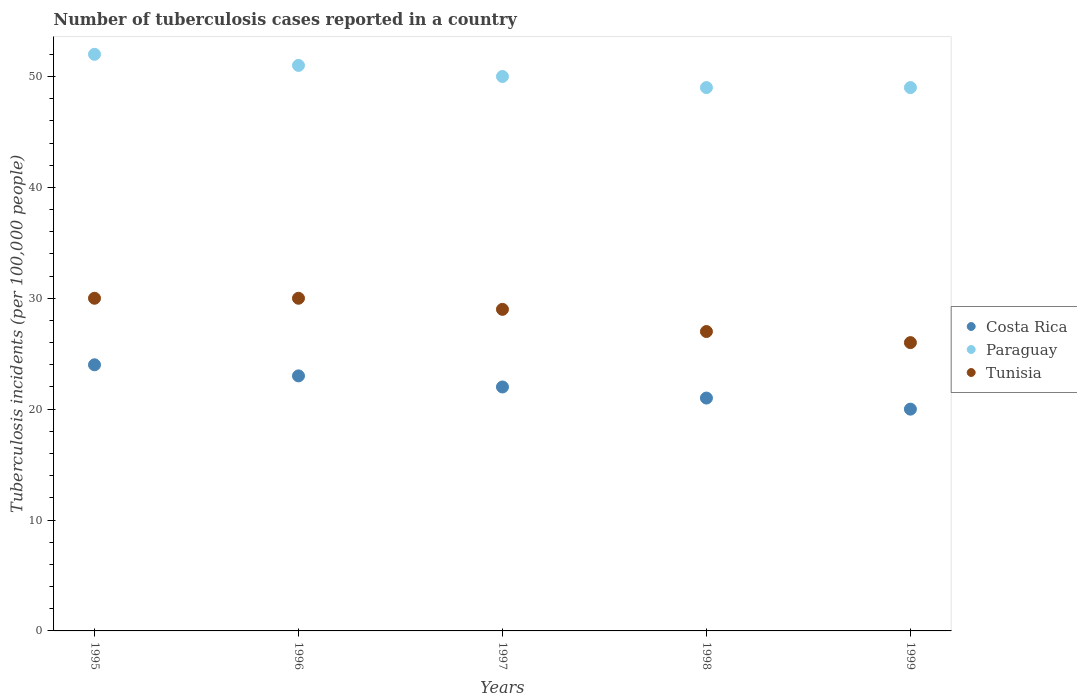What is the number of tuberculosis cases reported in in Paraguay in 1997?
Your answer should be very brief. 50. Across all years, what is the maximum number of tuberculosis cases reported in in Paraguay?
Ensure brevity in your answer.  52. Across all years, what is the minimum number of tuberculosis cases reported in in Tunisia?
Your response must be concise. 26. In which year was the number of tuberculosis cases reported in in Tunisia maximum?
Keep it short and to the point. 1995. What is the total number of tuberculosis cases reported in in Paraguay in the graph?
Provide a succinct answer. 251. What is the difference between the number of tuberculosis cases reported in in Paraguay in 1997 and that in 1999?
Your answer should be very brief. 1. What is the difference between the number of tuberculosis cases reported in in Paraguay in 1997 and the number of tuberculosis cases reported in in Tunisia in 1999?
Your response must be concise. 24. What is the average number of tuberculosis cases reported in in Tunisia per year?
Your answer should be very brief. 28.4. In the year 1996, what is the difference between the number of tuberculosis cases reported in in Costa Rica and number of tuberculosis cases reported in in Tunisia?
Give a very brief answer. -7. In how many years, is the number of tuberculosis cases reported in in Paraguay greater than 40?
Keep it short and to the point. 5. What is the ratio of the number of tuberculosis cases reported in in Costa Rica in 1996 to that in 1999?
Keep it short and to the point. 1.15. Is the number of tuberculosis cases reported in in Tunisia in 1996 less than that in 1997?
Ensure brevity in your answer.  No. Is the difference between the number of tuberculosis cases reported in in Costa Rica in 1995 and 1998 greater than the difference between the number of tuberculosis cases reported in in Tunisia in 1995 and 1998?
Make the answer very short. No. What is the difference between the highest and the second highest number of tuberculosis cases reported in in Tunisia?
Offer a terse response. 0. What is the difference between the highest and the lowest number of tuberculosis cases reported in in Costa Rica?
Your answer should be compact. 4. Is the sum of the number of tuberculosis cases reported in in Costa Rica in 1997 and 1998 greater than the maximum number of tuberculosis cases reported in in Paraguay across all years?
Your response must be concise. No. Is the number of tuberculosis cases reported in in Costa Rica strictly less than the number of tuberculosis cases reported in in Tunisia over the years?
Your answer should be very brief. Yes. How many years are there in the graph?
Provide a succinct answer. 5. Are the values on the major ticks of Y-axis written in scientific E-notation?
Your answer should be compact. No. Does the graph contain any zero values?
Offer a terse response. No. Does the graph contain grids?
Provide a succinct answer. No. How are the legend labels stacked?
Provide a succinct answer. Vertical. What is the title of the graph?
Make the answer very short. Number of tuberculosis cases reported in a country. What is the label or title of the X-axis?
Offer a terse response. Years. What is the label or title of the Y-axis?
Your answer should be compact. Tuberculosis incidents (per 100,0 people). What is the Tuberculosis incidents (per 100,000 people) in Paraguay in 1995?
Give a very brief answer. 52. What is the Tuberculosis incidents (per 100,000 people) in Tunisia in 1996?
Offer a terse response. 30. What is the Tuberculosis incidents (per 100,000 people) in Paraguay in 1997?
Keep it short and to the point. 50. What is the Tuberculosis incidents (per 100,000 people) of Costa Rica in 1998?
Your answer should be compact. 21. What is the Tuberculosis incidents (per 100,000 people) in Paraguay in 1999?
Offer a terse response. 49. What is the Tuberculosis incidents (per 100,000 people) of Tunisia in 1999?
Your answer should be very brief. 26. Across all years, what is the maximum Tuberculosis incidents (per 100,000 people) of Costa Rica?
Your response must be concise. 24. Across all years, what is the maximum Tuberculosis incidents (per 100,000 people) in Paraguay?
Ensure brevity in your answer.  52. Across all years, what is the maximum Tuberculosis incidents (per 100,000 people) of Tunisia?
Your answer should be very brief. 30. Across all years, what is the minimum Tuberculosis incidents (per 100,000 people) in Costa Rica?
Keep it short and to the point. 20. Across all years, what is the minimum Tuberculosis incidents (per 100,000 people) of Tunisia?
Keep it short and to the point. 26. What is the total Tuberculosis incidents (per 100,000 people) in Costa Rica in the graph?
Offer a very short reply. 110. What is the total Tuberculosis incidents (per 100,000 people) in Paraguay in the graph?
Keep it short and to the point. 251. What is the total Tuberculosis incidents (per 100,000 people) of Tunisia in the graph?
Your answer should be compact. 142. What is the difference between the Tuberculosis incidents (per 100,000 people) of Paraguay in 1995 and that in 1996?
Make the answer very short. 1. What is the difference between the Tuberculosis incidents (per 100,000 people) of Costa Rica in 1995 and that in 1997?
Offer a very short reply. 2. What is the difference between the Tuberculosis incidents (per 100,000 people) in Paraguay in 1995 and that in 1997?
Your response must be concise. 2. What is the difference between the Tuberculosis incidents (per 100,000 people) of Costa Rica in 1995 and that in 1998?
Make the answer very short. 3. What is the difference between the Tuberculosis incidents (per 100,000 people) in Paraguay in 1995 and that in 1998?
Your answer should be compact. 3. What is the difference between the Tuberculosis incidents (per 100,000 people) in Paraguay in 1995 and that in 1999?
Ensure brevity in your answer.  3. What is the difference between the Tuberculosis incidents (per 100,000 people) of Paraguay in 1996 and that in 1997?
Your answer should be compact. 1. What is the difference between the Tuberculosis incidents (per 100,000 people) of Paraguay in 1996 and that in 1998?
Your answer should be compact. 2. What is the difference between the Tuberculosis incidents (per 100,000 people) in Tunisia in 1996 and that in 1998?
Provide a short and direct response. 3. What is the difference between the Tuberculosis incidents (per 100,000 people) in Paraguay in 1996 and that in 1999?
Make the answer very short. 2. What is the difference between the Tuberculosis incidents (per 100,000 people) of Tunisia in 1996 and that in 1999?
Provide a short and direct response. 4. What is the difference between the Tuberculosis incidents (per 100,000 people) of Costa Rica in 1997 and that in 1998?
Provide a short and direct response. 1. What is the difference between the Tuberculosis incidents (per 100,000 people) in Paraguay in 1997 and that in 1998?
Ensure brevity in your answer.  1. What is the difference between the Tuberculosis incidents (per 100,000 people) of Tunisia in 1997 and that in 1998?
Ensure brevity in your answer.  2. What is the difference between the Tuberculosis incidents (per 100,000 people) in Costa Rica in 1997 and that in 1999?
Ensure brevity in your answer.  2. What is the difference between the Tuberculosis incidents (per 100,000 people) of Paraguay in 1997 and that in 1999?
Provide a succinct answer. 1. What is the difference between the Tuberculosis incidents (per 100,000 people) in Costa Rica in 1998 and that in 1999?
Keep it short and to the point. 1. What is the difference between the Tuberculosis incidents (per 100,000 people) in Paraguay in 1998 and that in 1999?
Provide a short and direct response. 0. What is the difference between the Tuberculosis incidents (per 100,000 people) in Tunisia in 1998 and that in 1999?
Offer a terse response. 1. What is the difference between the Tuberculosis incidents (per 100,000 people) of Costa Rica in 1995 and the Tuberculosis incidents (per 100,000 people) of Paraguay in 1996?
Your answer should be compact. -27. What is the difference between the Tuberculosis incidents (per 100,000 people) of Costa Rica in 1995 and the Tuberculosis incidents (per 100,000 people) of Tunisia in 1996?
Your answer should be compact. -6. What is the difference between the Tuberculosis incidents (per 100,000 people) of Costa Rica in 1995 and the Tuberculosis incidents (per 100,000 people) of Paraguay in 1997?
Offer a very short reply. -26. What is the difference between the Tuberculosis incidents (per 100,000 people) of Costa Rica in 1995 and the Tuberculosis incidents (per 100,000 people) of Tunisia in 1997?
Provide a short and direct response. -5. What is the difference between the Tuberculosis incidents (per 100,000 people) of Costa Rica in 1995 and the Tuberculosis incidents (per 100,000 people) of Paraguay in 1998?
Your answer should be very brief. -25. What is the difference between the Tuberculosis incidents (per 100,000 people) in Costa Rica in 1995 and the Tuberculosis incidents (per 100,000 people) in Tunisia in 1998?
Your answer should be very brief. -3. What is the difference between the Tuberculosis incidents (per 100,000 people) in Paraguay in 1995 and the Tuberculosis incidents (per 100,000 people) in Tunisia in 1998?
Make the answer very short. 25. What is the difference between the Tuberculosis incidents (per 100,000 people) of Costa Rica in 1995 and the Tuberculosis incidents (per 100,000 people) of Tunisia in 1999?
Your answer should be very brief. -2. What is the difference between the Tuberculosis incidents (per 100,000 people) of Costa Rica in 1996 and the Tuberculosis incidents (per 100,000 people) of Tunisia in 1997?
Provide a succinct answer. -6. What is the difference between the Tuberculosis incidents (per 100,000 people) of Paraguay in 1996 and the Tuberculosis incidents (per 100,000 people) of Tunisia in 1997?
Offer a terse response. 22. What is the difference between the Tuberculosis incidents (per 100,000 people) in Costa Rica in 1996 and the Tuberculosis incidents (per 100,000 people) in Paraguay in 1998?
Ensure brevity in your answer.  -26. What is the difference between the Tuberculosis incidents (per 100,000 people) of Costa Rica in 1996 and the Tuberculosis incidents (per 100,000 people) of Tunisia in 1998?
Your answer should be very brief. -4. What is the difference between the Tuberculosis incidents (per 100,000 people) of Costa Rica in 1996 and the Tuberculosis incidents (per 100,000 people) of Paraguay in 1999?
Make the answer very short. -26. What is the difference between the Tuberculosis incidents (per 100,000 people) of Costa Rica in 1996 and the Tuberculosis incidents (per 100,000 people) of Tunisia in 1999?
Keep it short and to the point. -3. What is the difference between the Tuberculosis incidents (per 100,000 people) of Paraguay in 1996 and the Tuberculosis incidents (per 100,000 people) of Tunisia in 1999?
Provide a short and direct response. 25. What is the difference between the Tuberculosis incidents (per 100,000 people) of Costa Rica in 1997 and the Tuberculosis incidents (per 100,000 people) of Paraguay in 1998?
Your response must be concise. -27. What is the difference between the Tuberculosis incidents (per 100,000 people) of Paraguay in 1997 and the Tuberculosis incidents (per 100,000 people) of Tunisia in 1998?
Make the answer very short. 23. What is the difference between the Tuberculosis incidents (per 100,000 people) of Costa Rica in 1997 and the Tuberculosis incidents (per 100,000 people) of Paraguay in 1999?
Ensure brevity in your answer.  -27. What is the difference between the Tuberculosis incidents (per 100,000 people) of Costa Rica in 1997 and the Tuberculosis incidents (per 100,000 people) of Tunisia in 1999?
Provide a short and direct response. -4. What is the difference between the Tuberculosis incidents (per 100,000 people) in Costa Rica in 1998 and the Tuberculosis incidents (per 100,000 people) in Paraguay in 1999?
Your answer should be very brief. -28. What is the difference between the Tuberculosis incidents (per 100,000 people) in Paraguay in 1998 and the Tuberculosis incidents (per 100,000 people) in Tunisia in 1999?
Offer a very short reply. 23. What is the average Tuberculosis incidents (per 100,000 people) of Paraguay per year?
Your answer should be very brief. 50.2. What is the average Tuberculosis incidents (per 100,000 people) of Tunisia per year?
Keep it short and to the point. 28.4. In the year 1995, what is the difference between the Tuberculosis incidents (per 100,000 people) in Costa Rica and Tuberculosis incidents (per 100,000 people) in Paraguay?
Offer a terse response. -28. In the year 1995, what is the difference between the Tuberculosis incidents (per 100,000 people) of Costa Rica and Tuberculosis incidents (per 100,000 people) of Tunisia?
Your answer should be very brief. -6. In the year 1995, what is the difference between the Tuberculosis incidents (per 100,000 people) of Paraguay and Tuberculosis incidents (per 100,000 people) of Tunisia?
Give a very brief answer. 22. In the year 1996, what is the difference between the Tuberculosis incidents (per 100,000 people) of Costa Rica and Tuberculosis incidents (per 100,000 people) of Tunisia?
Provide a succinct answer. -7. In the year 1996, what is the difference between the Tuberculosis incidents (per 100,000 people) in Paraguay and Tuberculosis incidents (per 100,000 people) in Tunisia?
Your answer should be compact. 21. In the year 1997, what is the difference between the Tuberculosis incidents (per 100,000 people) of Costa Rica and Tuberculosis incidents (per 100,000 people) of Paraguay?
Offer a very short reply. -28. In the year 1997, what is the difference between the Tuberculosis incidents (per 100,000 people) of Costa Rica and Tuberculosis incidents (per 100,000 people) of Tunisia?
Make the answer very short. -7. In the year 1997, what is the difference between the Tuberculosis incidents (per 100,000 people) of Paraguay and Tuberculosis incidents (per 100,000 people) of Tunisia?
Provide a succinct answer. 21. In the year 1998, what is the difference between the Tuberculosis incidents (per 100,000 people) of Costa Rica and Tuberculosis incidents (per 100,000 people) of Paraguay?
Keep it short and to the point. -28. In the year 1998, what is the difference between the Tuberculosis incidents (per 100,000 people) of Costa Rica and Tuberculosis incidents (per 100,000 people) of Tunisia?
Offer a very short reply. -6. In the year 1998, what is the difference between the Tuberculosis incidents (per 100,000 people) of Paraguay and Tuberculosis incidents (per 100,000 people) of Tunisia?
Offer a very short reply. 22. In the year 1999, what is the difference between the Tuberculosis incidents (per 100,000 people) in Costa Rica and Tuberculosis incidents (per 100,000 people) in Paraguay?
Keep it short and to the point. -29. What is the ratio of the Tuberculosis incidents (per 100,000 people) in Costa Rica in 1995 to that in 1996?
Keep it short and to the point. 1.04. What is the ratio of the Tuberculosis incidents (per 100,000 people) in Paraguay in 1995 to that in 1996?
Keep it short and to the point. 1.02. What is the ratio of the Tuberculosis incidents (per 100,000 people) in Paraguay in 1995 to that in 1997?
Make the answer very short. 1.04. What is the ratio of the Tuberculosis incidents (per 100,000 people) in Tunisia in 1995 to that in 1997?
Your answer should be very brief. 1.03. What is the ratio of the Tuberculosis incidents (per 100,000 people) in Costa Rica in 1995 to that in 1998?
Keep it short and to the point. 1.14. What is the ratio of the Tuberculosis incidents (per 100,000 people) of Paraguay in 1995 to that in 1998?
Give a very brief answer. 1.06. What is the ratio of the Tuberculosis incidents (per 100,000 people) in Tunisia in 1995 to that in 1998?
Provide a succinct answer. 1.11. What is the ratio of the Tuberculosis incidents (per 100,000 people) of Paraguay in 1995 to that in 1999?
Offer a very short reply. 1.06. What is the ratio of the Tuberculosis incidents (per 100,000 people) of Tunisia in 1995 to that in 1999?
Offer a very short reply. 1.15. What is the ratio of the Tuberculosis incidents (per 100,000 people) of Costa Rica in 1996 to that in 1997?
Provide a succinct answer. 1.05. What is the ratio of the Tuberculosis incidents (per 100,000 people) of Paraguay in 1996 to that in 1997?
Provide a succinct answer. 1.02. What is the ratio of the Tuberculosis incidents (per 100,000 people) of Tunisia in 1996 to that in 1997?
Your answer should be very brief. 1.03. What is the ratio of the Tuberculosis incidents (per 100,000 people) in Costa Rica in 1996 to that in 1998?
Make the answer very short. 1.1. What is the ratio of the Tuberculosis incidents (per 100,000 people) in Paraguay in 1996 to that in 1998?
Your response must be concise. 1.04. What is the ratio of the Tuberculosis incidents (per 100,000 people) of Costa Rica in 1996 to that in 1999?
Your response must be concise. 1.15. What is the ratio of the Tuberculosis incidents (per 100,000 people) in Paraguay in 1996 to that in 1999?
Your answer should be very brief. 1.04. What is the ratio of the Tuberculosis incidents (per 100,000 people) in Tunisia in 1996 to that in 1999?
Your answer should be compact. 1.15. What is the ratio of the Tuberculosis incidents (per 100,000 people) of Costa Rica in 1997 to that in 1998?
Offer a very short reply. 1.05. What is the ratio of the Tuberculosis incidents (per 100,000 people) in Paraguay in 1997 to that in 1998?
Make the answer very short. 1.02. What is the ratio of the Tuberculosis incidents (per 100,000 people) of Tunisia in 1997 to that in 1998?
Your answer should be compact. 1.07. What is the ratio of the Tuberculosis incidents (per 100,000 people) of Costa Rica in 1997 to that in 1999?
Ensure brevity in your answer.  1.1. What is the ratio of the Tuberculosis incidents (per 100,000 people) in Paraguay in 1997 to that in 1999?
Your response must be concise. 1.02. What is the ratio of the Tuberculosis incidents (per 100,000 people) of Tunisia in 1997 to that in 1999?
Keep it short and to the point. 1.12. What is the ratio of the Tuberculosis incidents (per 100,000 people) of Paraguay in 1998 to that in 1999?
Provide a short and direct response. 1. What is the difference between the highest and the second highest Tuberculosis incidents (per 100,000 people) in Costa Rica?
Keep it short and to the point. 1. What is the difference between the highest and the second highest Tuberculosis incidents (per 100,000 people) of Tunisia?
Your answer should be compact. 0. What is the difference between the highest and the lowest Tuberculosis incidents (per 100,000 people) in Paraguay?
Give a very brief answer. 3. What is the difference between the highest and the lowest Tuberculosis incidents (per 100,000 people) of Tunisia?
Make the answer very short. 4. 